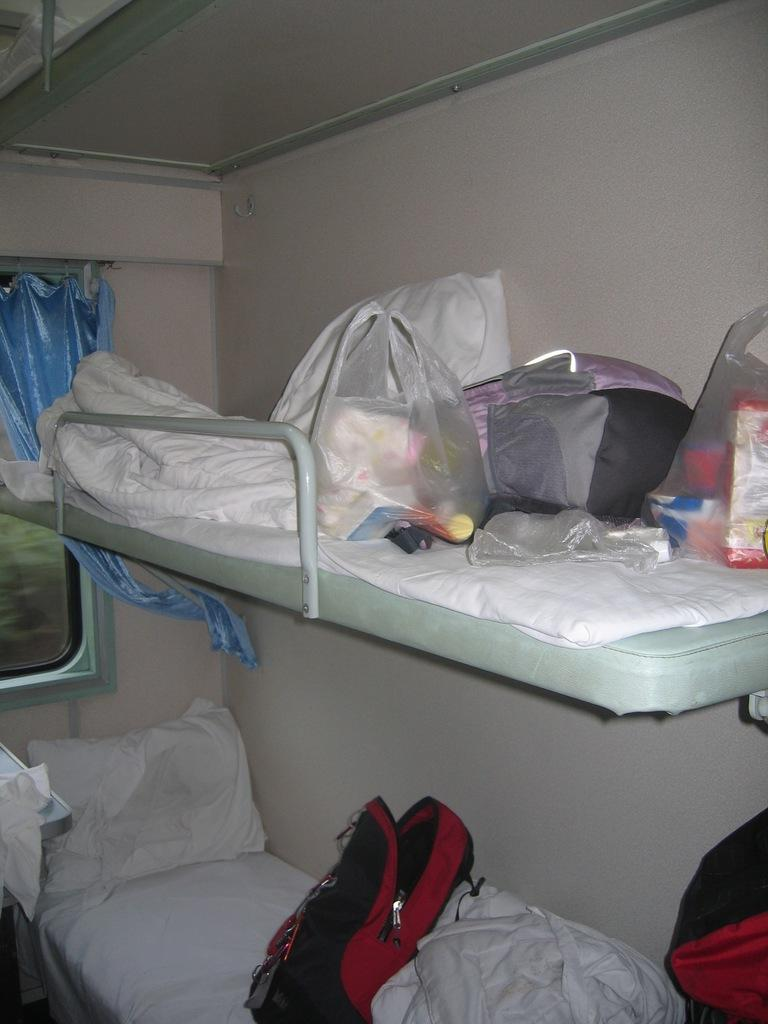What type of vehicle might the image be taken inside? The image is likely taken inside a train. What can be found in the train for passengers to sit on? There are seats in the image. What items are provided for passengers' comfort? There are blankets and pillows in the image. What objects are placed on the seats? There are objects on the seats in the image. What type of window treatment is present in the image? There is a curtain in the image. What is a feature of the train that allows passengers to see outside? There is a window in the image. Can you see any waves crashing on the shore in the image? There are no waves or shore visible in the image; it is taken inside a train. What type of holiday is being celebrated in the image? There is no indication of a holiday being celebrated in the image. 